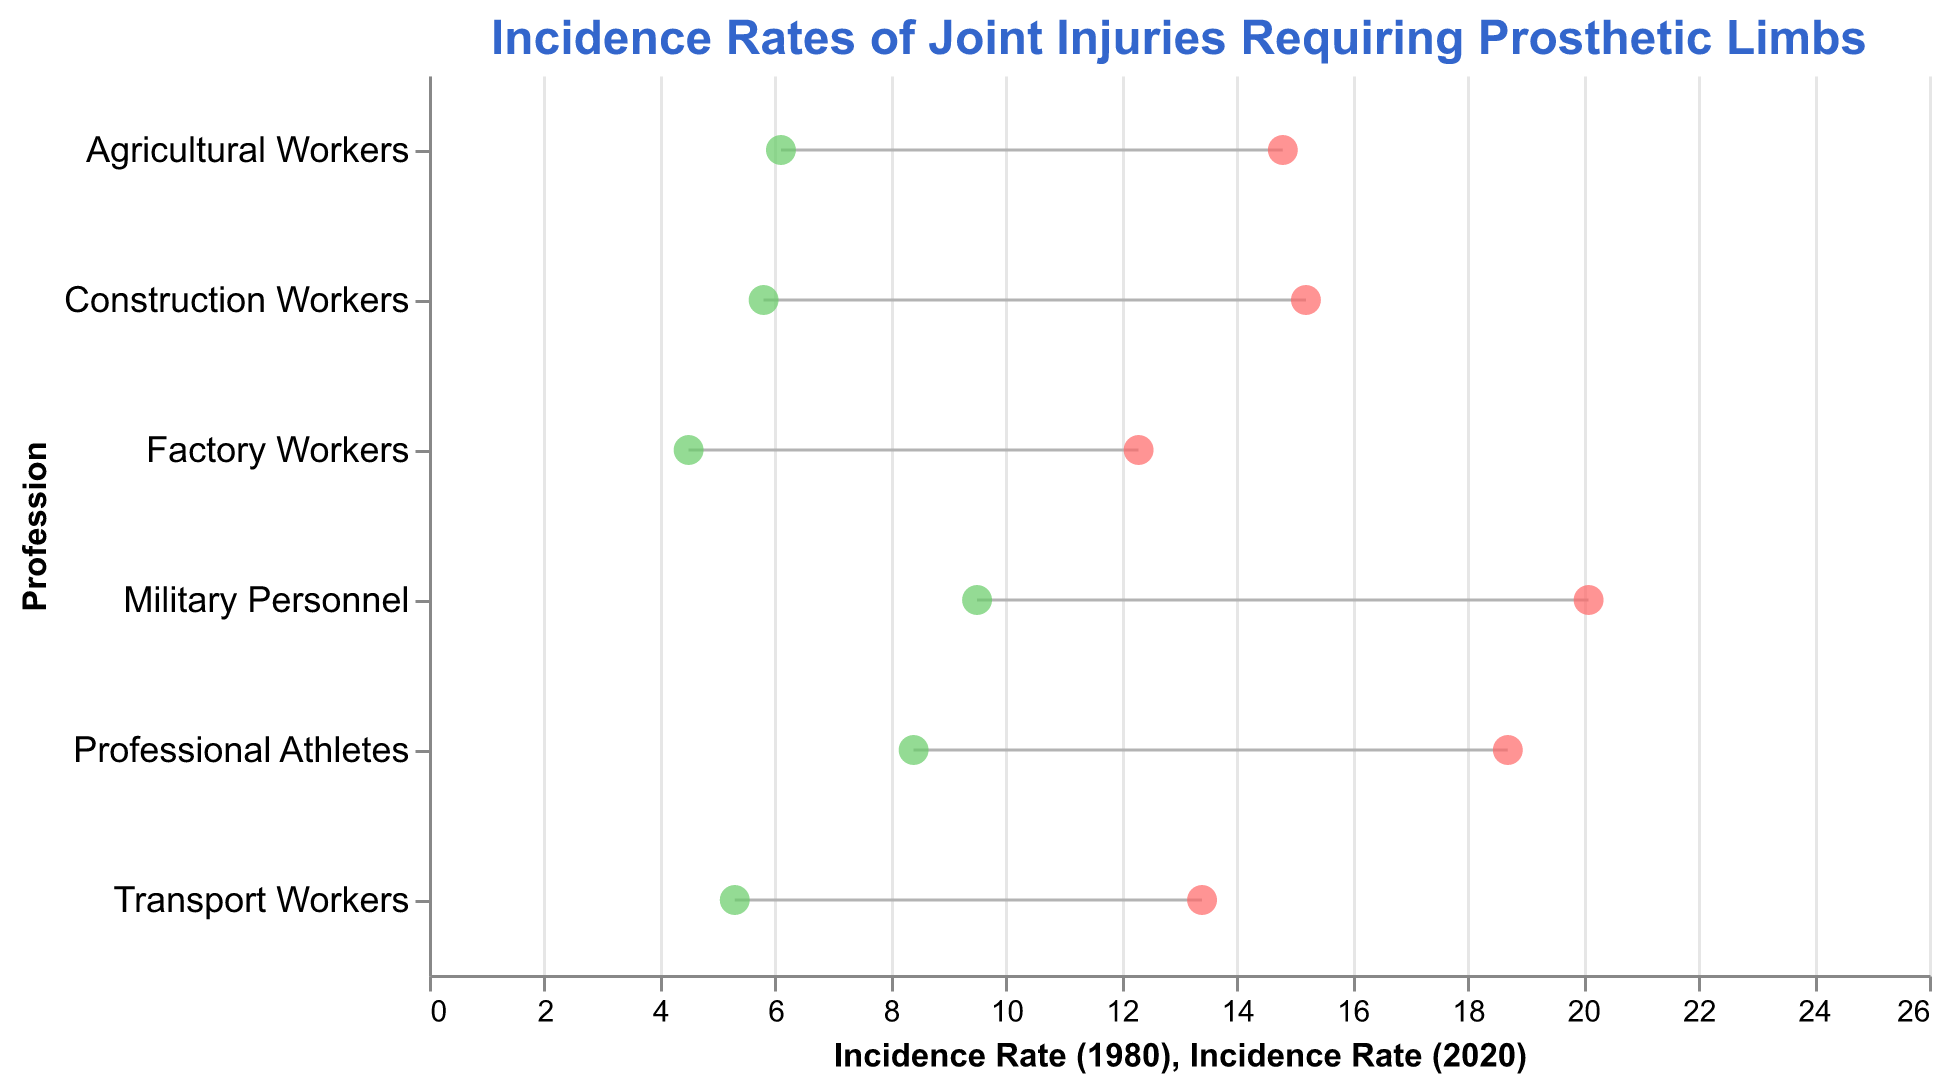What is the title of the plot? The title of the plot is displayed at the top in bold Arial font. This tells us the subject of the plot.
Answer: Incidence Rates of Joint Injuries Requiring Prosthetic Limbs What are the professions listed on the y-axis? The y-axis shows the list of professions in descending order based on their incidence rates in 1980. The plot visibly displays each profession name alongside the axis.
Answer: Construction Workers, Professional Athletes, Factory Workers, Military Personnel, Agricultural Workers, Transport Workers What color represents the incidence rate in 2020 on the plot? The plot uses two different colors for the dots representing the incidence rates from different years. The color for 2020 incidence rates is green.
Answer: Green Which profession had the highest incidence rate of joint injuries requiring prosthetic limbs in 1980? By observing the leftmost dots (representing 1980 rates) and their positions along the y-axis, we can identify the profession with the highest position on the axis.
Answer: Military Personnel Which profession saw the biggest decrease in incidence rates from 1980 to 2020? To find which profession saw the biggest decrease, we compare the distance between the two dots (1980 and 2020) linked by a grey line. The longer the gray line, the larger the decrease.
Answer: Construction Workers How much did the incidence rate for Professional Athletes drop from 1980 to 2020? We subtract the incidence rate of 2020 from the rate of 1980 for Professional Athletes. By looking at the values next to the y-axis, the calculation is: 18.7 - 8.4.
Answer: 10.3 Which profession had the lowest incidence rate of joint injuries requiring prosthetic limbs in 2020? By observing the rightmost dots (representing 2020 rates), the one closest to the zero value is the lowest. We then check which profession that dot is connected to on the y-axis.
Answer: Factory Workers What is the average incidence rate of joint injuries in 1980 across all professions? Add all the incidence rates of 1980 for each profession and divide by the number of professions: (15.2 + 18.7 + 12.3 + 20.1 + 14.8 + 13.4) / 6 = 94.5 / 6.
Answer: 15.75 Did any profession have increased incidence rates from 1980 to 2020? To determine if any profession saw an increase, we scan across all grey lines to see if any line goes from a lower value in 1980 to a higher value in 2020.
Answer: No What can you infer from the overall trend observed in the plot? The general observation shows that all the professions marked with lines and dots exhibit a significant decrease in incidence rates from 1980 to 2020, indicating advancements in safety measures or medical technologies.
Answer: A significant decrease in incidence rates across all professions 